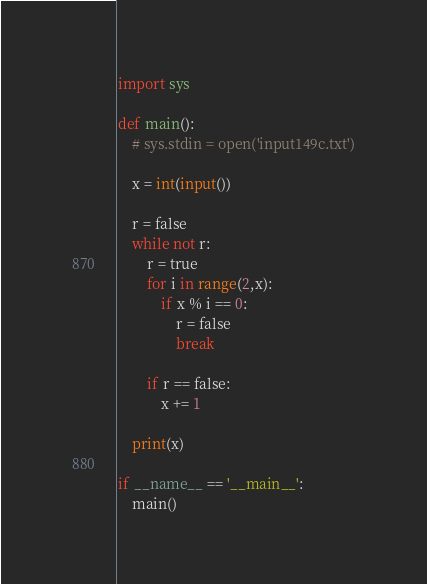<code> <loc_0><loc_0><loc_500><loc_500><_Python_>import sys

def main():
    # sys.stdin = open('input149c.txt')

    x = int(input())

    r = false
    while not r:
        r = true
        for i in range(2,x):
            if x % i == 0:
                r = false
                break

        if r == false:
            x += 1
        
    print(x)

if __name__ == '__main__':
    main()
</code> 